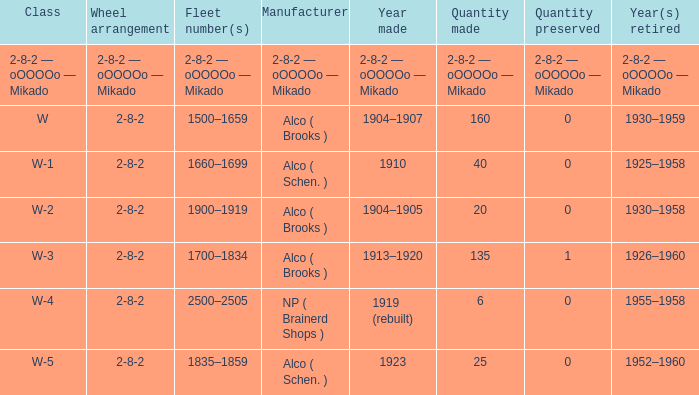Which locomotive class with a 2-8-2 wheel configuration has 25 units produced? W-5. 